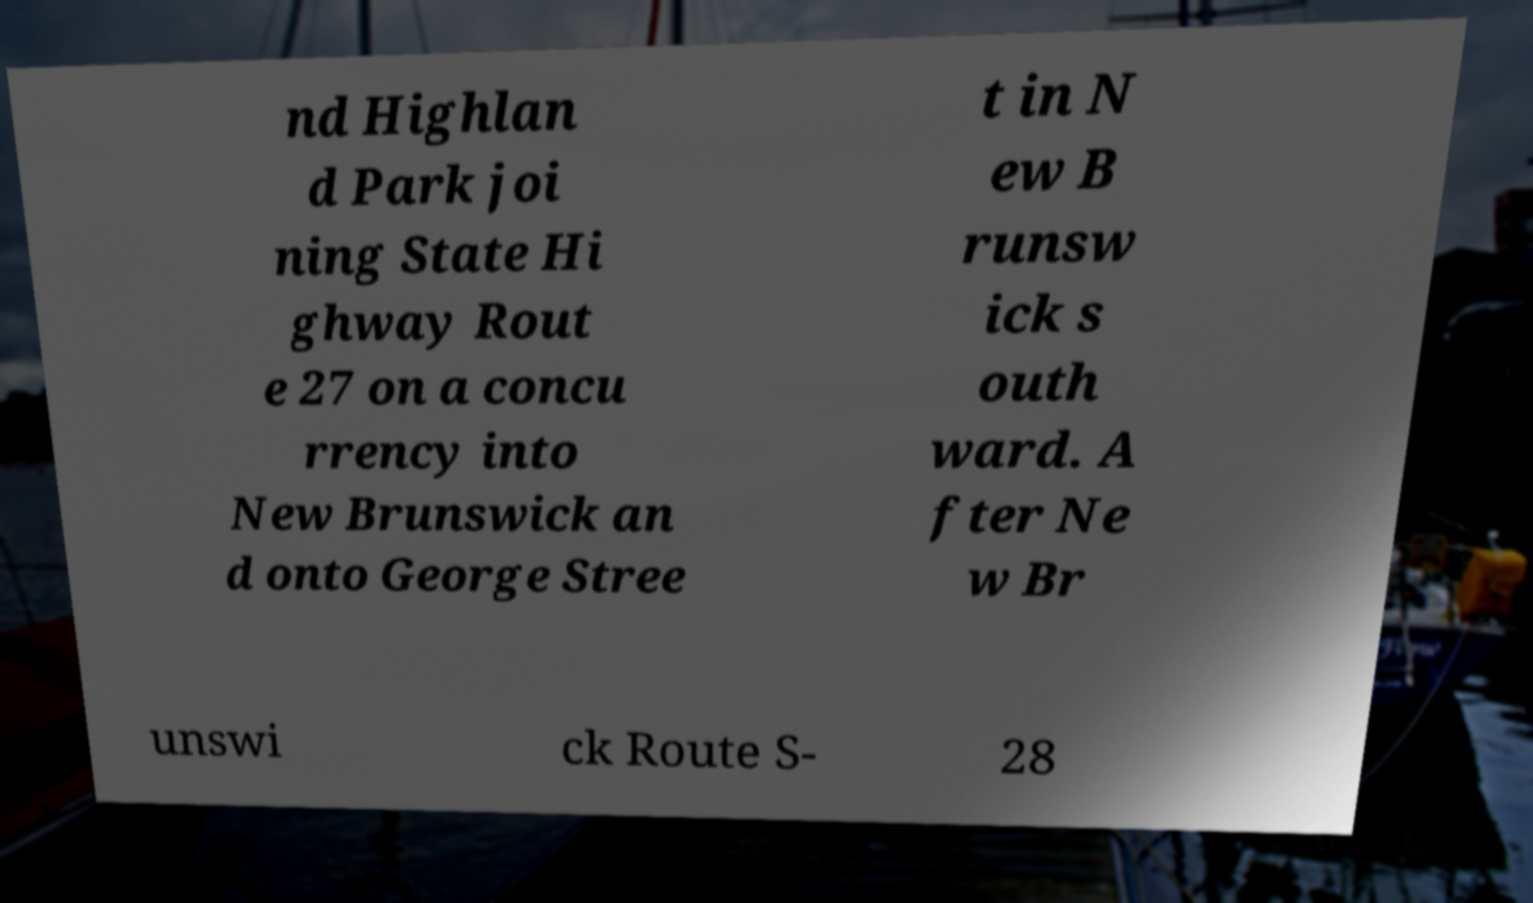There's text embedded in this image that I need extracted. Can you transcribe it verbatim? nd Highlan d Park joi ning State Hi ghway Rout e 27 on a concu rrency into New Brunswick an d onto George Stree t in N ew B runsw ick s outh ward. A fter Ne w Br unswi ck Route S- 28 